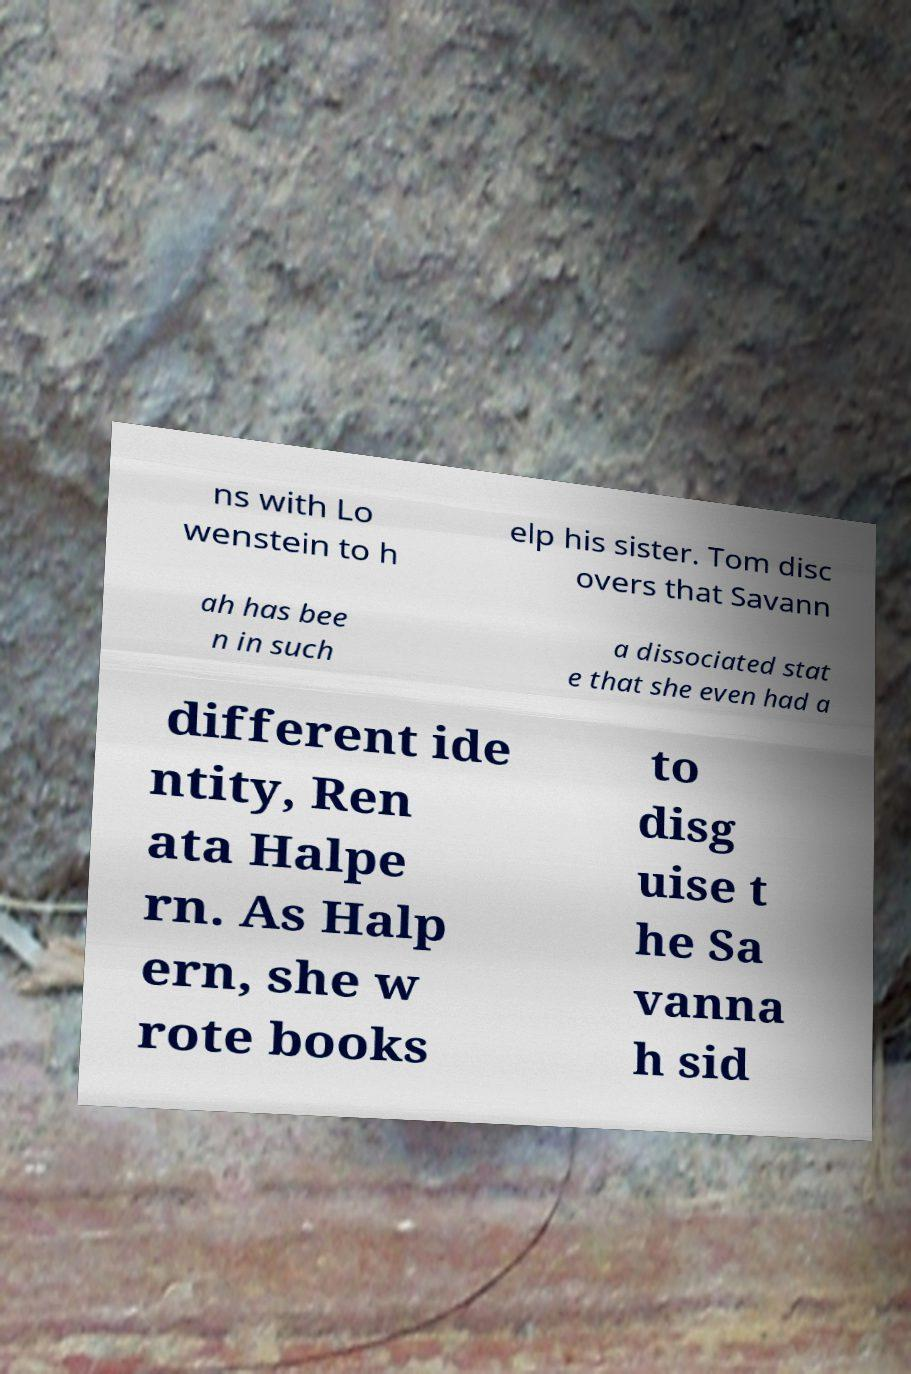Please identify and transcribe the text found in this image. ns with Lo wenstein to h elp his sister. Tom disc overs that Savann ah has bee n in such a dissociated stat e that she even had a different ide ntity, Ren ata Halpe rn. As Halp ern, she w rote books to disg uise t he Sa vanna h sid 